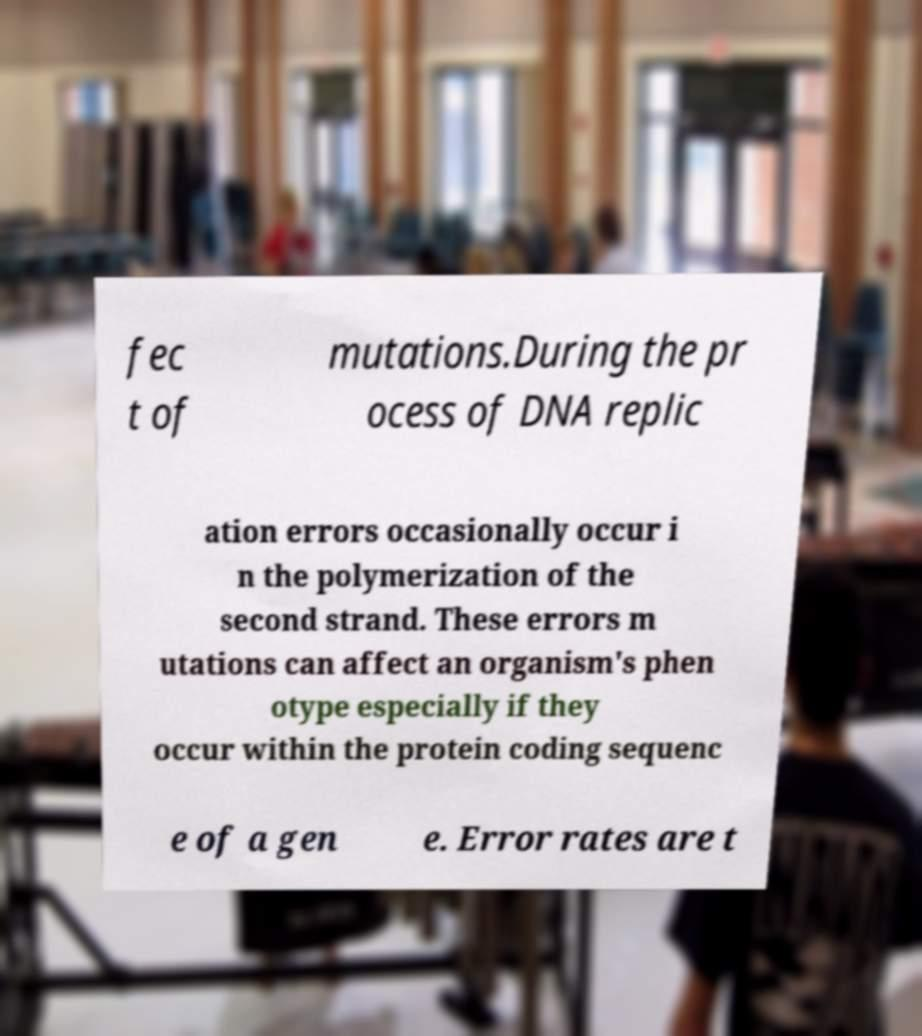Can you read and provide the text displayed in the image?This photo seems to have some interesting text. Can you extract and type it out for me? fec t of mutations.During the pr ocess of DNA replic ation errors occasionally occur i n the polymerization of the second strand. These errors m utations can affect an organism's phen otype especially if they occur within the protein coding sequenc e of a gen e. Error rates are t 